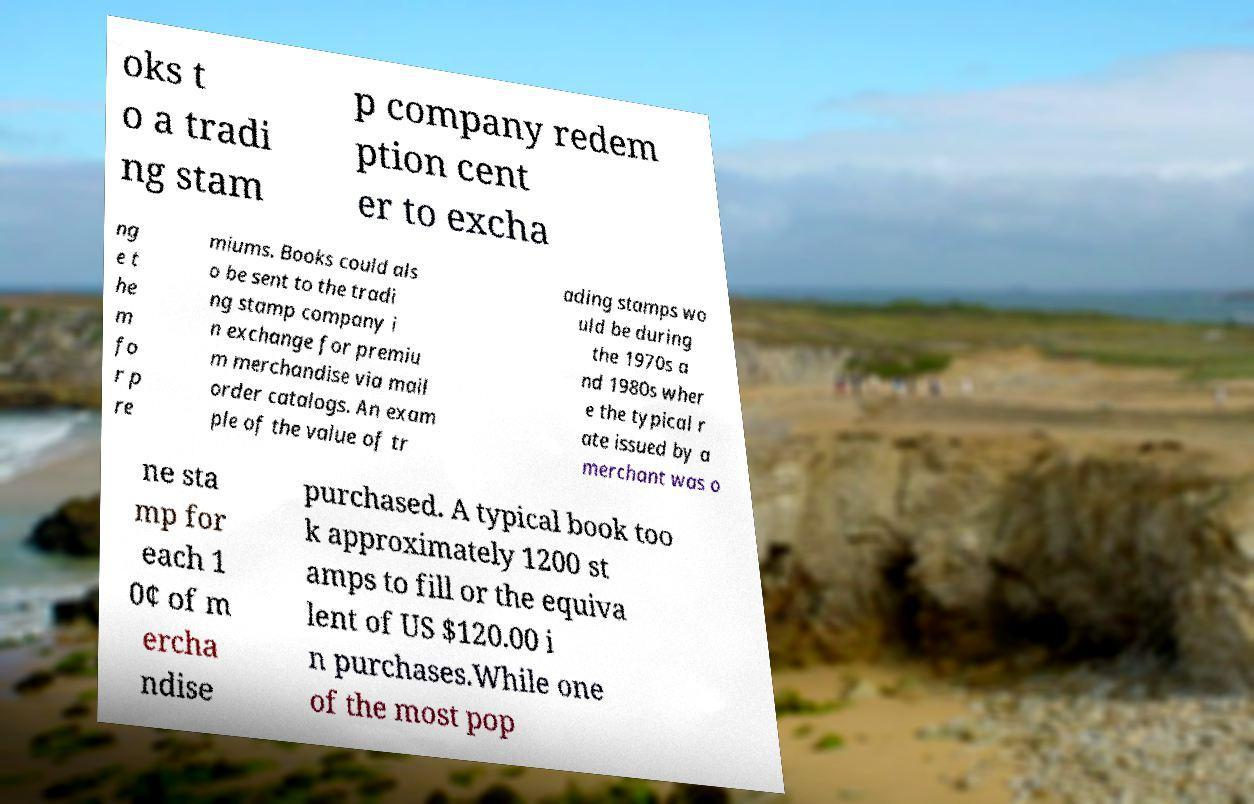Please read and relay the text visible in this image. What does it say? oks t o a tradi ng stam p company redem ption cent er to excha ng e t he m fo r p re miums. Books could als o be sent to the tradi ng stamp company i n exchange for premiu m merchandise via mail order catalogs. An exam ple of the value of tr ading stamps wo uld be during the 1970s a nd 1980s wher e the typical r ate issued by a merchant was o ne sta mp for each 1 0¢ of m ercha ndise purchased. A typical book too k approximately 1200 st amps to fill or the equiva lent of US $120.00 i n purchases.While one of the most pop 